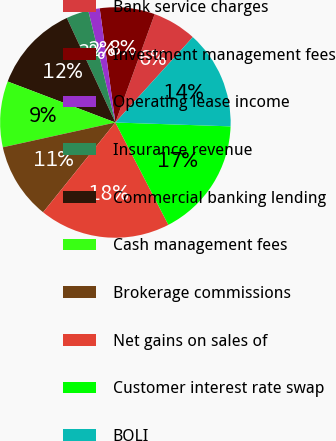Convert chart to OTSL. <chart><loc_0><loc_0><loc_500><loc_500><pie_chart><fcel>Bank service charges<fcel>Investment management fees<fcel>Operating lease income<fcel>Insurance revenue<fcel>Commercial banking lending<fcel>Cash management fees<fcel>Brokerage commissions<fcel>Net gains on sales of<fcel>Customer interest rate swap<fcel>BOLI<nl><fcel>6.19%<fcel>7.71%<fcel>1.61%<fcel>3.14%<fcel>12.29%<fcel>9.24%<fcel>10.76%<fcel>18.39%<fcel>16.86%<fcel>13.81%<nl></chart> 